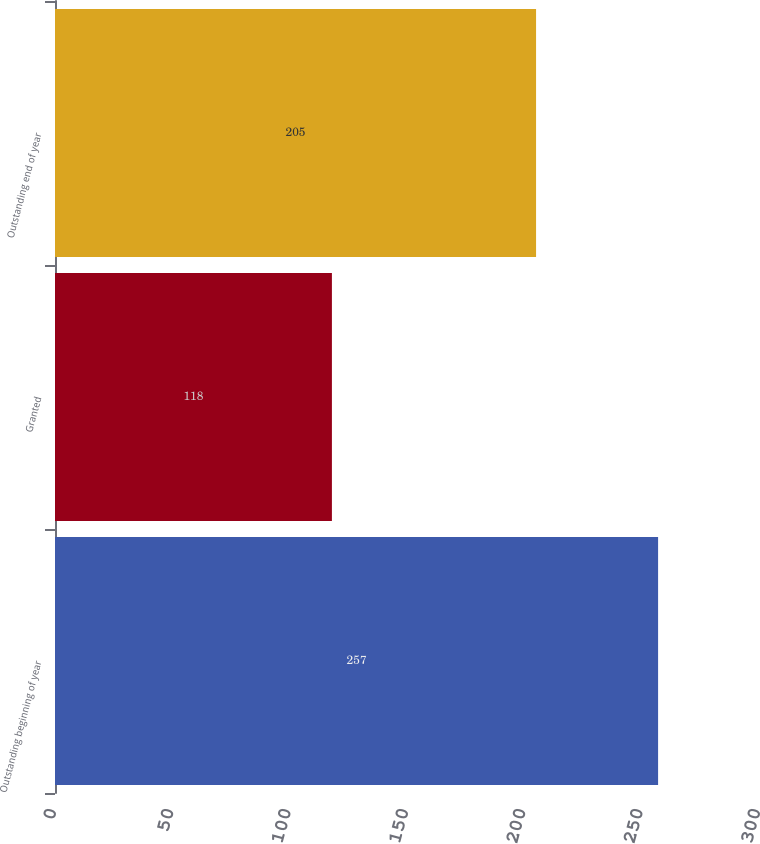Convert chart. <chart><loc_0><loc_0><loc_500><loc_500><bar_chart><fcel>Outstanding beginning of year<fcel>Granted<fcel>Outstanding end of year<nl><fcel>257<fcel>118<fcel>205<nl></chart> 